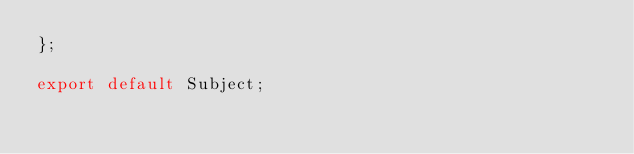<code> <loc_0><loc_0><loc_500><loc_500><_TypeScript_>};

export default Subject;
</code> 